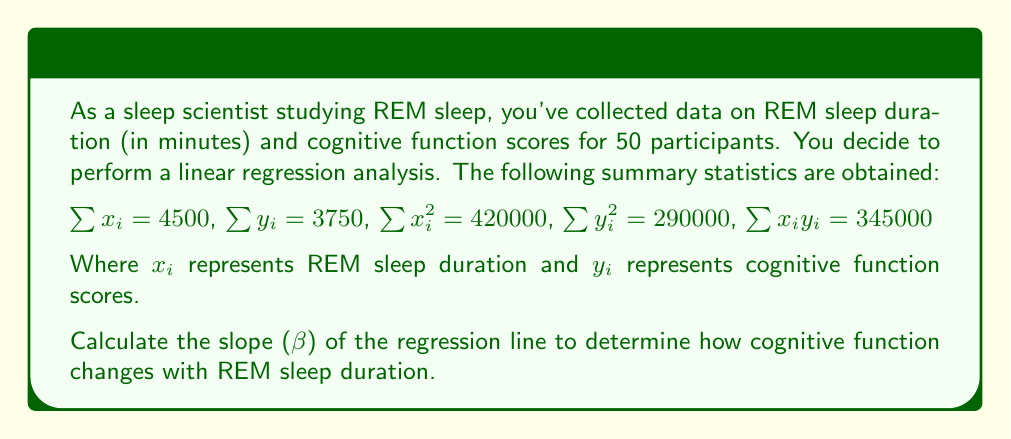Help me with this question. To calculate the slope (β) of the regression line, we'll use the formula:

$$β = \frac{n\sum x_iy_i - \sum x_i\sum y_i}{n\sum x_i^2 - (\sum x_i)^2}$$

Where n is the number of participants (50 in this case).

Step 1: Calculate $n\sum x_iy_i$
$50 \times 345000 = 17250000$

Step 2: Calculate $\sum x_i\sum y_i$
$4500 \times 3750 = 16875000$

Step 3: Calculate the numerator
$17250000 - 16875000 = 375000$

Step 4: Calculate $n\sum x_i^2$
$50 \times 420000 = 21000000$

Step 5: Calculate $(\sum x_i)^2$
$4500^2 = 20250000$

Step 6: Calculate the denominator
$21000000 - 20250000 = 750000$

Step 7: Divide the numerator by the denominator
$$β = \frac{375000}{750000} = 0.5$$
Answer: $β = 0.5$ 